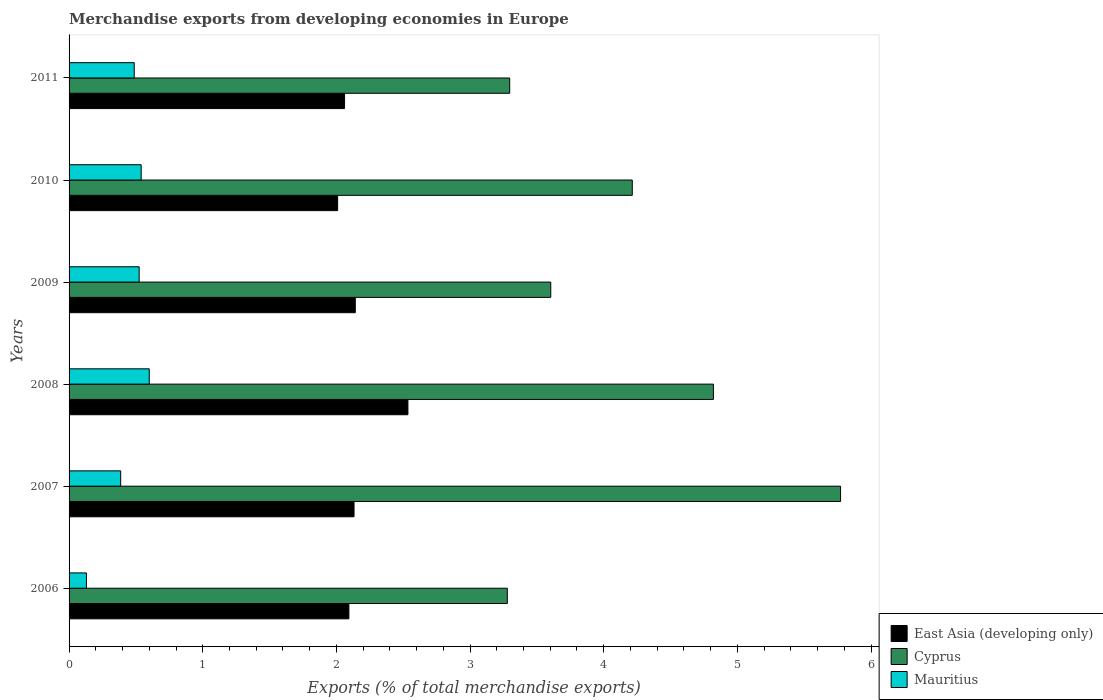Are the number of bars per tick equal to the number of legend labels?
Offer a very short reply. Yes. How many bars are there on the 4th tick from the bottom?
Ensure brevity in your answer.  3. What is the percentage of total merchandise exports in Mauritius in 2008?
Your answer should be very brief. 0.6. Across all years, what is the maximum percentage of total merchandise exports in Mauritius?
Provide a short and direct response. 0.6. Across all years, what is the minimum percentage of total merchandise exports in East Asia (developing only)?
Your response must be concise. 2.01. In which year was the percentage of total merchandise exports in Cyprus maximum?
Your answer should be very brief. 2007. What is the total percentage of total merchandise exports in Cyprus in the graph?
Your response must be concise. 24.99. What is the difference between the percentage of total merchandise exports in East Asia (developing only) in 2008 and that in 2010?
Offer a terse response. 0.53. What is the difference between the percentage of total merchandise exports in Cyprus in 2006 and the percentage of total merchandise exports in Mauritius in 2009?
Make the answer very short. 2.75. What is the average percentage of total merchandise exports in Cyprus per year?
Keep it short and to the point. 4.16. In the year 2009, what is the difference between the percentage of total merchandise exports in East Asia (developing only) and percentage of total merchandise exports in Mauritius?
Your answer should be compact. 1.62. In how many years, is the percentage of total merchandise exports in Mauritius greater than 0.2 %?
Ensure brevity in your answer.  5. What is the ratio of the percentage of total merchandise exports in East Asia (developing only) in 2007 to that in 2009?
Offer a terse response. 1. Is the difference between the percentage of total merchandise exports in East Asia (developing only) in 2008 and 2009 greater than the difference between the percentage of total merchandise exports in Mauritius in 2008 and 2009?
Offer a very short reply. Yes. What is the difference between the highest and the second highest percentage of total merchandise exports in East Asia (developing only)?
Your answer should be compact. 0.39. What is the difference between the highest and the lowest percentage of total merchandise exports in Mauritius?
Provide a succinct answer. 0.47. What does the 3rd bar from the top in 2006 represents?
Offer a terse response. East Asia (developing only). What does the 2nd bar from the bottom in 2010 represents?
Offer a very short reply. Cyprus. Is it the case that in every year, the sum of the percentage of total merchandise exports in Mauritius and percentage of total merchandise exports in East Asia (developing only) is greater than the percentage of total merchandise exports in Cyprus?
Make the answer very short. No. Are all the bars in the graph horizontal?
Your answer should be compact. Yes. How many years are there in the graph?
Offer a terse response. 6. Are the values on the major ticks of X-axis written in scientific E-notation?
Keep it short and to the point. No. Where does the legend appear in the graph?
Keep it short and to the point. Bottom right. How many legend labels are there?
Provide a short and direct response. 3. How are the legend labels stacked?
Keep it short and to the point. Vertical. What is the title of the graph?
Your answer should be very brief. Merchandise exports from developing economies in Europe. Does "Singapore" appear as one of the legend labels in the graph?
Make the answer very short. No. What is the label or title of the X-axis?
Give a very brief answer. Exports (% of total merchandise exports). What is the Exports (% of total merchandise exports) of East Asia (developing only) in 2006?
Provide a succinct answer. 2.09. What is the Exports (% of total merchandise exports) in Cyprus in 2006?
Keep it short and to the point. 3.28. What is the Exports (% of total merchandise exports) of Mauritius in 2006?
Offer a very short reply. 0.13. What is the Exports (% of total merchandise exports) in East Asia (developing only) in 2007?
Give a very brief answer. 2.13. What is the Exports (% of total merchandise exports) of Cyprus in 2007?
Your response must be concise. 5.77. What is the Exports (% of total merchandise exports) of Mauritius in 2007?
Provide a short and direct response. 0.39. What is the Exports (% of total merchandise exports) of East Asia (developing only) in 2008?
Offer a very short reply. 2.54. What is the Exports (% of total merchandise exports) of Cyprus in 2008?
Offer a terse response. 4.82. What is the Exports (% of total merchandise exports) of Mauritius in 2008?
Your answer should be compact. 0.6. What is the Exports (% of total merchandise exports) in East Asia (developing only) in 2009?
Offer a terse response. 2.14. What is the Exports (% of total merchandise exports) of Cyprus in 2009?
Your answer should be compact. 3.6. What is the Exports (% of total merchandise exports) in Mauritius in 2009?
Your response must be concise. 0.52. What is the Exports (% of total merchandise exports) of East Asia (developing only) in 2010?
Your answer should be compact. 2.01. What is the Exports (% of total merchandise exports) of Cyprus in 2010?
Provide a succinct answer. 4.21. What is the Exports (% of total merchandise exports) of Mauritius in 2010?
Provide a short and direct response. 0.54. What is the Exports (% of total merchandise exports) in East Asia (developing only) in 2011?
Offer a very short reply. 2.06. What is the Exports (% of total merchandise exports) in Cyprus in 2011?
Provide a succinct answer. 3.3. What is the Exports (% of total merchandise exports) in Mauritius in 2011?
Provide a short and direct response. 0.49. Across all years, what is the maximum Exports (% of total merchandise exports) in East Asia (developing only)?
Your answer should be compact. 2.54. Across all years, what is the maximum Exports (% of total merchandise exports) in Cyprus?
Provide a succinct answer. 5.77. Across all years, what is the maximum Exports (% of total merchandise exports) in Mauritius?
Give a very brief answer. 0.6. Across all years, what is the minimum Exports (% of total merchandise exports) of East Asia (developing only)?
Your answer should be compact. 2.01. Across all years, what is the minimum Exports (% of total merchandise exports) in Cyprus?
Your answer should be compact. 3.28. Across all years, what is the minimum Exports (% of total merchandise exports) of Mauritius?
Give a very brief answer. 0.13. What is the total Exports (% of total merchandise exports) in East Asia (developing only) in the graph?
Keep it short and to the point. 12.97. What is the total Exports (% of total merchandise exports) of Cyprus in the graph?
Your answer should be compact. 24.99. What is the total Exports (% of total merchandise exports) of Mauritius in the graph?
Your answer should be very brief. 2.67. What is the difference between the Exports (% of total merchandise exports) of East Asia (developing only) in 2006 and that in 2007?
Provide a succinct answer. -0.04. What is the difference between the Exports (% of total merchandise exports) in Cyprus in 2006 and that in 2007?
Ensure brevity in your answer.  -2.49. What is the difference between the Exports (% of total merchandise exports) in Mauritius in 2006 and that in 2007?
Your answer should be compact. -0.26. What is the difference between the Exports (% of total merchandise exports) in East Asia (developing only) in 2006 and that in 2008?
Provide a short and direct response. -0.44. What is the difference between the Exports (% of total merchandise exports) in Cyprus in 2006 and that in 2008?
Make the answer very short. -1.54. What is the difference between the Exports (% of total merchandise exports) in Mauritius in 2006 and that in 2008?
Your response must be concise. -0.47. What is the difference between the Exports (% of total merchandise exports) of East Asia (developing only) in 2006 and that in 2009?
Provide a short and direct response. -0.05. What is the difference between the Exports (% of total merchandise exports) in Cyprus in 2006 and that in 2009?
Make the answer very short. -0.33. What is the difference between the Exports (% of total merchandise exports) of Mauritius in 2006 and that in 2009?
Keep it short and to the point. -0.39. What is the difference between the Exports (% of total merchandise exports) in East Asia (developing only) in 2006 and that in 2010?
Your answer should be very brief. 0.08. What is the difference between the Exports (% of total merchandise exports) in Cyprus in 2006 and that in 2010?
Your answer should be compact. -0.94. What is the difference between the Exports (% of total merchandise exports) of Mauritius in 2006 and that in 2010?
Give a very brief answer. -0.41. What is the difference between the Exports (% of total merchandise exports) of East Asia (developing only) in 2006 and that in 2011?
Ensure brevity in your answer.  0.03. What is the difference between the Exports (% of total merchandise exports) in Cyprus in 2006 and that in 2011?
Offer a very short reply. -0.02. What is the difference between the Exports (% of total merchandise exports) of Mauritius in 2006 and that in 2011?
Your answer should be very brief. -0.36. What is the difference between the Exports (% of total merchandise exports) of East Asia (developing only) in 2007 and that in 2008?
Keep it short and to the point. -0.4. What is the difference between the Exports (% of total merchandise exports) of Cyprus in 2007 and that in 2008?
Offer a very short reply. 0.95. What is the difference between the Exports (% of total merchandise exports) in Mauritius in 2007 and that in 2008?
Your response must be concise. -0.21. What is the difference between the Exports (% of total merchandise exports) of East Asia (developing only) in 2007 and that in 2009?
Your response must be concise. -0.01. What is the difference between the Exports (% of total merchandise exports) of Cyprus in 2007 and that in 2009?
Provide a short and direct response. 2.17. What is the difference between the Exports (% of total merchandise exports) of Mauritius in 2007 and that in 2009?
Your answer should be compact. -0.14. What is the difference between the Exports (% of total merchandise exports) in East Asia (developing only) in 2007 and that in 2010?
Ensure brevity in your answer.  0.12. What is the difference between the Exports (% of total merchandise exports) of Cyprus in 2007 and that in 2010?
Ensure brevity in your answer.  1.56. What is the difference between the Exports (% of total merchandise exports) of Mauritius in 2007 and that in 2010?
Your response must be concise. -0.15. What is the difference between the Exports (% of total merchandise exports) in East Asia (developing only) in 2007 and that in 2011?
Offer a terse response. 0.07. What is the difference between the Exports (% of total merchandise exports) in Cyprus in 2007 and that in 2011?
Offer a very short reply. 2.48. What is the difference between the Exports (% of total merchandise exports) of Mauritius in 2007 and that in 2011?
Keep it short and to the point. -0.1. What is the difference between the Exports (% of total merchandise exports) in East Asia (developing only) in 2008 and that in 2009?
Your answer should be compact. 0.39. What is the difference between the Exports (% of total merchandise exports) in Cyprus in 2008 and that in 2009?
Your answer should be very brief. 1.22. What is the difference between the Exports (% of total merchandise exports) in Mauritius in 2008 and that in 2009?
Keep it short and to the point. 0.08. What is the difference between the Exports (% of total merchandise exports) in East Asia (developing only) in 2008 and that in 2010?
Give a very brief answer. 0.53. What is the difference between the Exports (% of total merchandise exports) in Cyprus in 2008 and that in 2010?
Provide a short and direct response. 0.61. What is the difference between the Exports (% of total merchandise exports) in Mauritius in 2008 and that in 2010?
Make the answer very short. 0.06. What is the difference between the Exports (% of total merchandise exports) in East Asia (developing only) in 2008 and that in 2011?
Ensure brevity in your answer.  0.47. What is the difference between the Exports (% of total merchandise exports) in Cyprus in 2008 and that in 2011?
Your answer should be compact. 1.52. What is the difference between the Exports (% of total merchandise exports) in Mauritius in 2008 and that in 2011?
Offer a terse response. 0.11. What is the difference between the Exports (% of total merchandise exports) of East Asia (developing only) in 2009 and that in 2010?
Offer a very short reply. 0.13. What is the difference between the Exports (% of total merchandise exports) in Cyprus in 2009 and that in 2010?
Your response must be concise. -0.61. What is the difference between the Exports (% of total merchandise exports) of Mauritius in 2009 and that in 2010?
Your answer should be compact. -0.02. What is the difference between the Exports (% of total merchandise exports) of East Asia (developing only) in 2009 and that in 2011?
Your answer should be very brief. 0.08. What is the difference between the Exports (% of total merchandise exports) of Cyprus in 2009 and that in 2011?
Provide a succinct answer. 0.31. What is the difference between the Exports (% of total merchandise exports) in Mauritius in 2009 and that in 2011?
Provide a short and direct response. 0.04. What is the difference between the Exports (% of total merchandise exports) of East Asia (developing only) in 2010 and that in 2011?
Provide a short and direct response. -0.05. What is the difference between the Exports (% of total merchandise exports) in Cyprus in 2010 and that in 2011?
Your response must be concise. 0.92. What is the difference between the Exports (% of total merchandise exports) in Mauritius in 2010 and that in 2011?
Ensure brevity in your answer.  0.05. What is the difference between the Exports (% of total merchandise exports) in East Asia (developing only) in 2006 and the Exports (% of total merchandise exports) in Cyprus in 2007?
Provide a succinct answer. -3.68. What is the difference between the Exports (% of total merchandise exports) in East Asia (developing only) in 2006 and the Exports (% of total merchandise exports) in Mauritius in 2007?
Offer a terse response. 1.71. What is the difference between the Exports (% of total merchandise exports) in Cyprus in 2006 and the Exports (% of total merchandise exports) in Mauritius in 2007?
Provide a short and direct response. 2.89. What is the difference between the Exports (% of total merchandise exports) of East Asia (developing only) in 2006 and the Exports (% of total merchandise exports) of Cyprus in 2008?
Your response must be concise. -2.73. What is the difference between the Exports (% of total merchandise exports) of East Asia (developing only) in 2006 and the Exports (% of total merchandise exports) of Mauritius in 2008?
Offer a very short reply. 1.49. What is the difference between the Exports (% of total merchandise exports) in Cyprus in 2006 and the Exports (% of total merchandise exports) in Mauritius in 2008?
Your answer should be compact. 2.68. What is the difference between the Exports (% of total merchandise exports) in East Asia (developing only) in 2006 and the Exports (% of total merchandise exports) in Cyprus in 2009?
Provide a succinct answer. -1.51. What is the difference between the Exports (% of total merchandise exports) in East Asia (developing only) in 2006 and the Exports (% of total merchandise exports) in Mauritius in 2009?
Make the answer very short. 1.57. What is the difference between the Exports (% of total merchandise exports) in Cyprus in 2006 and the Exports (% of total merchandise exports) in Mauritius in 2009?
Ensure brevity in your answer.  2.75. What is the difference between the Exports (% of total merchandise exports) in East Asia (developing only) in 2006 and the Exports (% of total merchandise exports) in Cyprus in 2010?
Provide a short and direct response. -2.12. What is the difference between the Exports (% of total merchandise exports) of East Asia (developing only) in 2006 and the Exports (% of total merchandise exports) of Mauritius in 2010?
Your answer should be very brief. 1.55. What is the difference between the Exports (% of total merchandise exports) in Cyprus in 2006 and the Exports (% of total merchandise exports) in Mauritius in 2010?
Offer a terse response. 2.74. What is the difference between the Exports (% of total merchandise exports) of East Asia (developing only) in 2006 and the Exports (% of total merchandise exports) of Cyprus in 2011?
Give a very brief answer. -1.2. What is the difference between the Exports (% of total merchandise exports) in East Asia (developing only) in 2006 and the Exports (% of total merchandise exports) in Mauritius in 2011?
Keep it short and to the point. 1.61. What is the difference between the Exports (% of total merchandise exports) of Cyprus in 2006 and the Exports (% of total merchandise exports) of Mauritius in 2011?
Offer a very short reply. 2.79. What is the difference between the Exports (% of total merchandise exports) in East Asia (developing only) in 2007 and the Exports (% of total merchandise exports) in Cyprus in 2008?
Give a very brief answer. -2.69. What is the difference between the Exports (% of total merchandise exports) in East Asia (developing only) in 2007 and the Exports (% of total merchandise exports) in Mauritius in 2008?
Your answer should be compact. 1.53. What is the difference between the Exports (% of total merchandise exports) of Cyprus in 2007 and the Exports (% of total merchandise exports) of Mauritius in 2008?
Offer a terse response. 5.17. What is the difference between the Exports (% of total merchandise exports) of East Asia (developing only) in 2007 and the Exports (% of total merchandise exports) of Cyprus in 2009?
Provide a succinct answer. -1.47. What is the difference between the Exports (% of total merchandise exports) of East Asia (developing only) in 2007 and the Exports (% of total merchandise exports) of Mauritius in 2009?
Give a very brief answer. 1.61. What is the difference between the Exports (% of total merchandise exports) of Cyprus in 2007 and the Exports (% of total merchandise exports) of Mauritius in 2009?
Provide a succinct answer. 5.25. What is the difference between the Exports (% of total merchandise exports) of East Asia (developing only) in 2007 and the Exports (% of total merchandise exports) of Cyprus in 2010?
Your answer should be compact. -2.08. What is the difference between the Exports (% of total merchandise exports) in East Asia (developing only) in 2007 and the Exports (% of total merchandise exports) in Mauritius in 2010?
Provide a short and direct response. 1.59. What is the difference between the Exports (% of total merchandise exports) in Cyprus in 2007 and the Exports (% of total merchandise exports) in Mauritius in 2010?
Offer a terse response. 5.23. What is the difference between the Exports (% of total merchandise exports) of East Asia (developing only) in 2007 and the Exports (% of total merchandise exports) of Cyprus in 2011?
Offer a terse response. -1.16. What is the difference between the Exports (% of total merchandise exports) in East Asia (developing only) in 2007 and the Exports (% of total merchandise exports) in Mauritius in 2011?
Your response must be concise. 1.64. What is the difference between the Exports (% of total merchandise exports) in Cyprus in 2007 and the Exports (% of total merchandise exports) in Mauritius in 2011?
Make the answer very short. 5.28. What is the difference between the Exports (% of total merchandise exports) in East Asia (developing only) in 2008 and the Exports (% of total merchandise exports) in Cyprus in 2009?
Provide a short and direct response. -1.07. What is the difference between the Exports (% of total merchandise exports) in East Asia (developing only) in 2008 and the Exports (% of total merchandise exports) in Mauritius in 2009?
Your answer should be very brief. 2.01. What is the difference between the Exports (% of total merchandise exports) in Cyprus in 2008 and the Exports (% of total merchandise exports) in Mauritius in 2009?
Provide a succinct answer. 4.3. What is the difference between the Exports (% of total merchandise exports) in East Asia (developing only) in 2008 and the Exports (% of total merchandise exports) in Cyprus in 2010?
Offer a very short reply. -1.68. What is the difference between the Exports (% of total merchandise exports) of East Asia (developing only) in 2008 and the Exports (% of total merchandise exports) of Mauritius in 2010?
Provide a succinct answer. 2. What is the difference between the Exports (% of total merchandise exports) in Cyprus in 2008 and the Exports (% of total merchandise exports) in Mauritius in 2010?
Your response must be concise. 4.28. What is the difference between the Exports (% of total merchandise exports) in East Asia (developing only) in 2008 and the Exports (% of total merchandise exports) in Cyprus in 2011?
Offer a very short reply. -0.76. What is the difference between the Exports (% of total merchandise exports) of East Asia (developing only) in 2008 and the Exports (% of total merchandise exports) of Mauritius in 2011?
Provide a short and direct response. 2.05. What is the difference between the Exports (% of total merchandise exports) of Cyprus in 2008 and the Exports (% of total merchandise exports) of Mauritius in 2011?
Offer a very short reply. 4.33. What is the difference between the Exports (% of total merchandise exports) in East Asia (developing only) in 2009 and the Exports (% of total merchandise exports) in Cyprus in 2010?
Keep it short and to the point. -2.07. What is the difference between the Exports (% of total merchandise exports) in East Asia (developing only) in 2009 and the Exports (% of total merchandise exports) in Mauritius in 2010?
Provide a succinct answer. 1.6. What is the difference between the Exports (% of total merchandise exports) of Cyprus in 2009 and the Exports (% of total merchandise exports) of Mauritius in 2010?
Keep it short and to the point. 3.06. What is the difference between the Exports (% of total merchandise exports) in East Asia (developing only) in 2009 and the Exports (% of total merchandise exports) in Cyprus in 2011?
Offer a terse response. -1.16. What is the difference between the Exports (% of total merchandise exports) of East Asia (developing only) in 2009 and the Exports (% of total merchandise exports) of Mauritius in 2011?
Your answer should be very brief. 1.65. What is the difference between the Exports (% of total merchandise exports) in Cyprus in 2009 and the Exports (% of total merchandise exports) in Mauritius in 2011?
Provide a short and direct response. 3.12. What is the difference between the Exports (% of total merchandise exports) of East Asia (developing only) in 2010 and the Exports (% of total merchandise exports) of Cyprus in 2011?
Your answer should be very brief. -1.29. What is the difference between the Exports (% of total merchandise exports) in East Asia (developing only) in 2010 and the Exports (% of total merchandise exports) in Mauritius in 2011?
Offer a very short reply. 1.52. What is the difference between the Exports (% of total merchandise exports) in Cyprus in 2010 and the Exports (% of total merchandise exports) in Mauritius in 2011?
Provide a short and direct response. 3.73. What is the average Exports (% of total merchandise exports) of East Asia (developing only) per year?
Make the answer very short. 2.16. What is the average Exports (% of total merchandise exports) of Cyprus per year?
Your answer should be compact. 4.16. What is the average Exports (% of total merchandise exports) in Mauritius per year?
Give a very brief answer. 0.44. In the year 2006, what is the difference between the Exports (% of total merchandise exports) in East Asia (developing only) and Exports (% of total merchandise exports) in Cyprus?
Your answer should be very brief. -1.19. In the year 2006, what is the difference between the Exports (% of total merchandise exports) of East Asia (developing only) and Exports (% of total merchandise exports) of Mauritius?
Ensure brevity in your answer.  1.96. In the year 2006, what is the difference between the Exports (% of total merchandise exports) of Cyprus and Exports (% of total merchandise exports) of Mauritius?
Give a very brief answer. 3.15. In the year 2007, what is the difference between the Exports (% of total merchandise exports) of East Asia (developing only) and Exports (% of total merchandise exports) of Cyprus?
Provide a short and direct response. -3.64. In the year 2007, what is the difference between the Exports (% of total merchandise exports) of East Asia (developing only) and Exports (% of total merchandise exports) of Mauritius?
Make the answer very short. 1.75. In the year 2007, what is the difference between the Exports (% of total merchandise exports) in Cyprus and Exports (% of total merchandise exports) in Mauritius?
Provide a short and direct response. 5.39. In the year 2008, what is the difference between the Exports (% of total merchandise exports) of East Asia (developing only) and Exports (% of total merchandise exports) of Cyprus?
Provide a succinct answer. -2.29. In the year 2008, what is the difference between the Exports (% of total merchandise exports) in East Asia (developing only) and Exports (% of total merchandise exports) in Mauritius?
Give a very brief answer. 1.94. In the year 2008, what is the difference between the Exports (% of total merchandise exports) in Cyprus and Exports (% of total merchandise exports) in Mauritius?
Your response must be concise. 4.22. In the year 2009, what is the difference between the Exports (% of total merchandise exports) of East Asia (developing only) and Exports (% of total merchandise exports) of Cyprus?
Your answer should be compact. -1.46. In the year 2009, what is the difference between the Exports (% of total merchandise exports) of East Asia (developing only) and Exports (% of total merchandise exports) of Mauritius?
Provide a short and direct response. 1.62. In the year 2009, what is the difference between the Exports (% of total merchandise exports) of Cyprus and Exports (% of total merchandise exports) of Mauritius?
Keep it short and to the point. 3.08. In the year 2010, what is the difference between the Exports (% of total merchandise exports) in East Asia (developing only) and Exports (% of total merchandise exports) in Cyprus?
Offer a terse response. -2.2. In the year 2010, what is the difference between the Exports (% of total merchandise exports) of East Asia (developing only) and Exports (% of total merchandise exports) of Mauritius?
Provide a succinct answer. 1.47. In the year 2010, what is the difference between the Exports (% of total merchandise exports) of Cyprus and Exports (% of total merchandise exports) of Mauritius?
Give a very brief answer. 3.67. In the year 2011, what is the difference between the Exports (% of total merchandise exports) in East Asia (developing only) and Exports (% of total merchandise exports) in Cyprus?
Offer a terse response. -1.24. In the year 2011, what is the difference between the Exports (% of total merchandise exports) in East Asia (developing only) and Exports (% of total merchandise exports) in Mauritius?
Offer a very short reply. 1.57. In the year 2011, what is the difference between the Exports (% of total merchandise exports) of Cyprus and Exports (% of total merchandise exports) of Mauritius?
Make the answer very short. 2.81. What is the ratio of the Exports (% of total merchandise exports) in Cyprus in 2006 to that in 2007?
Your answer should be very brief. 0.57. What is the ratio of the Exports (% of total merchandise exports) in Mauritius in 2006 to that in 2007?
Keep it short and to the point. 0.34. What is the ratio of the Exports (% of total merchandise exports) in East Asia (developing only) in 2006 to that in 2008?
Your answer should be compact. 0.83. What is the ratio of the Exports (% of total merchandise exports) of Cyprus in 2006 to that in 2008?
Give a very brief answer. 0.68. What is the ratio of the Exports (% of total merchandise exports) in Mauritius in 2006 to that in 2008?
Make the answer very short. 0.22. What is the ratio of the Exports (% of total merchandise exports) in East Asia (developing only) in 2006 to that in 2009?
Keep it short and to the point. 0.98. What is the ratio of the Exports (% of total merchandise exports) in Cyprus in 2006 to that in 2009?
Make the answer very short. 0.91. What is the ratio of the Exports (% of total merchandise exports) in Mauritius in 2006 to that in 2009?
Your answer should be very brief. 0.25. What is the ratio of the Exports (% of total merchandise exports) of East Asia (developing only) in 2006 to that in 2010?
Ensure brevity in your answer.  1.04. What is the ratio of the Exports (% of total merchandise exports) of Cyprus in 2006 to that in 2010?
Your answer should be very brief. 0.78. What is the ratio of the Exports (% of total merchandise exports) in Mauritius in 2006 to that in 2010?
Ensure brevity in your answer.  0.24. What is the ratio of the Exports (% of total merchandise exports) of East Asia (developing only) in 2006 to that in 2011?
Make the answer very short. 1.02. What is the ratio of the Exports (% of total merchandise exports) of Cyprus in 2006 to that in 2011?
Provide a short and direct response. 0.99. What is the ratio of the Exports (% of total merchandise exports) of Mauritius in 2006 to that in 2011?
Give a very brief answer. 0.27. What is the ratio of the Exports (% of total merchandise exports) of East Asia (developing only) in 2007 to that in 2008?
Your answer should be compact. 0.84. What is the ratio of the Exports (% of total merchandise exports) of Cyprus in 2007 to that in 2008?
Give a very brief answer. 1.2. What is the ratio of the Exports (% of total merchandise exports) of Mauritius in 2007 to that in 2008?
Your answer should be compact. 0.64. What is the ratio of the Exports (% of total merchandise exports) of Cyprus in 2007 to that in 2009?
Provide a short and direct response. 1.6. What is the ratio of the Exports (% of total merchandise exports) of Mauritius in 2007 to that in 2009?
Offer a very short reply. 0.74. What is the ratio of the Exports (% of total merchandise exports) of East Asia (developing only) in 2007 to that in 2010?
Your answer should be very brief. 1.06. What is the ratio of the Exports (% of total merchandise exports) in Cyprus in 2007 to that in 2010?
Offer a terse response. 1.37. What is the ratio of the Exports (% of total merchandise exports) in Mauritius in 2007 to that in 2010?
Keep it short and to the point. 0.72. What is the ratio of the Exports (% of total merchandise exports) in East Asia (developing only) in 2007 to that in 2011?
Provide a succinct answer. 1.03. What is the ratio of the Exports (% of total merchandise exports) of Cyprus in 2007 to that in 2011?
Your answer should be very brief. 1.75. What is the ratio of the Exports (% of total merchandise exports) in Mauritius in 2007 to that in 2011?
Your answer should be compact. 0.79. What is the ratio of the Exports (% of total merchandise exports) in East Asia (developing only) in 2008 to that in 2009?
Your response must be concise. 1.18. What is the ratio of the Exports (% of total merchandise exports) in Cyprus in 2008 to that in 2009?
Give a very brief answer. 1.34. What is the ratio of the Exports (% of total merchandise exports) in Mauritius in 2008 to that in 2009?
Your response must be concise. 1.14. What is the ratio of the Exports (% of total merchandise exports) in East Asia (developing only) in 2008 to that in 2010?
Give a very brief answer. 1.26. What is the ratio of the Exports (% of total merchandise exports) in Cyprus in 2008 to that in 2010?
Your answer should be compact. 1.14. What is the ratio of the Exports (% of total merchandise exports) of Mauritius in 2008 to that in 2010?
Your answer should be compact. 1.11. What is the ratio of the Exports (% of total merchandise exports) of East Asia (developing only) in 2008 to that in 2011?
Make the answer very short. 1.23. What is the ratio of the Exports (% of total merchandise exports) of Cyprus in 2008 to that in 2011?
Provide a succinct answer. 1.46. What is the ratio of the Exports (% of total merchandise exports) in Mauritius in 2008 to that in 2011?
Your answer should be compact. 1.23. What is the ratio of the Exports (% of total merchandise exports) in East Asia (developing only) in 2009 to that in 2010?
Provide a succinct answer. 1.07. What is the ratio of the Exports (% of total merchandise exports) in Cyprus in 2009 to that in 2010?
Offer a very short reply. 0.86. What is the ratio of the Exports (% of total merchandise exports) in Mauritius in 2009 to that in 2010?
Provide a succinct answer. 0.97. What is the ratio of the Exports (% of total merchandise exports) of East Asia (developing only) in 2009 to that in 2011?
Keep it short and to the point. 1.04. What is the ratio of the Exports (% of total merchandise exports) in Cyprus in 2009 to that in 2011?
Give a very brief answer. 1.09. What is the ratio of the Exports (% of total merchandise exports) in Mauritius in 2009 to that in 2011?
Keep it short and to the point. 1.08. What is the ratio of the Exports (% of total merchandise exports) of East Asia (developing only) in 2010 to that in 2011?
Provide a succinct answer. 0.97. What is the ratio of the Exports (% of total merchandise exports) in Cyprus in 2010 to that in 2011?
Your answer should be compact. 1.28. What is the ratio of the Exports (% of total merchandise exports) of Mauritius in 2010 to that in 2011?
Give a very brief answer. 1.11. What is the difference between the highest and the second highest Exports (% of total merchandise exports) in East Asia (developing only)?
Keep it short and to the point. 0.39. What is the difference between the highest and the second highest Exports (% of total merchandise exports) in Cyprus?
Provide a short and direct response. 0.95. What is the difference between the highest and the second highest Exports (% of total merchandise exports) in Mauritius?
Your answer should be very brief. 0.06. What is the difference between the highest and the lowest Exports (% of total merchandise exports) in East Asia (developing only)?
Give a very brief answer. 0.53. What is the difference between the highest and the lowest Exports (% of total merchandise exports) of Cyprus?
Provide a succinct answer. 2.49. What is the difference between the highest and the lowest Exports (% of total merchandise exports) in Mauritius?
Your response must be concise. 0.47. 